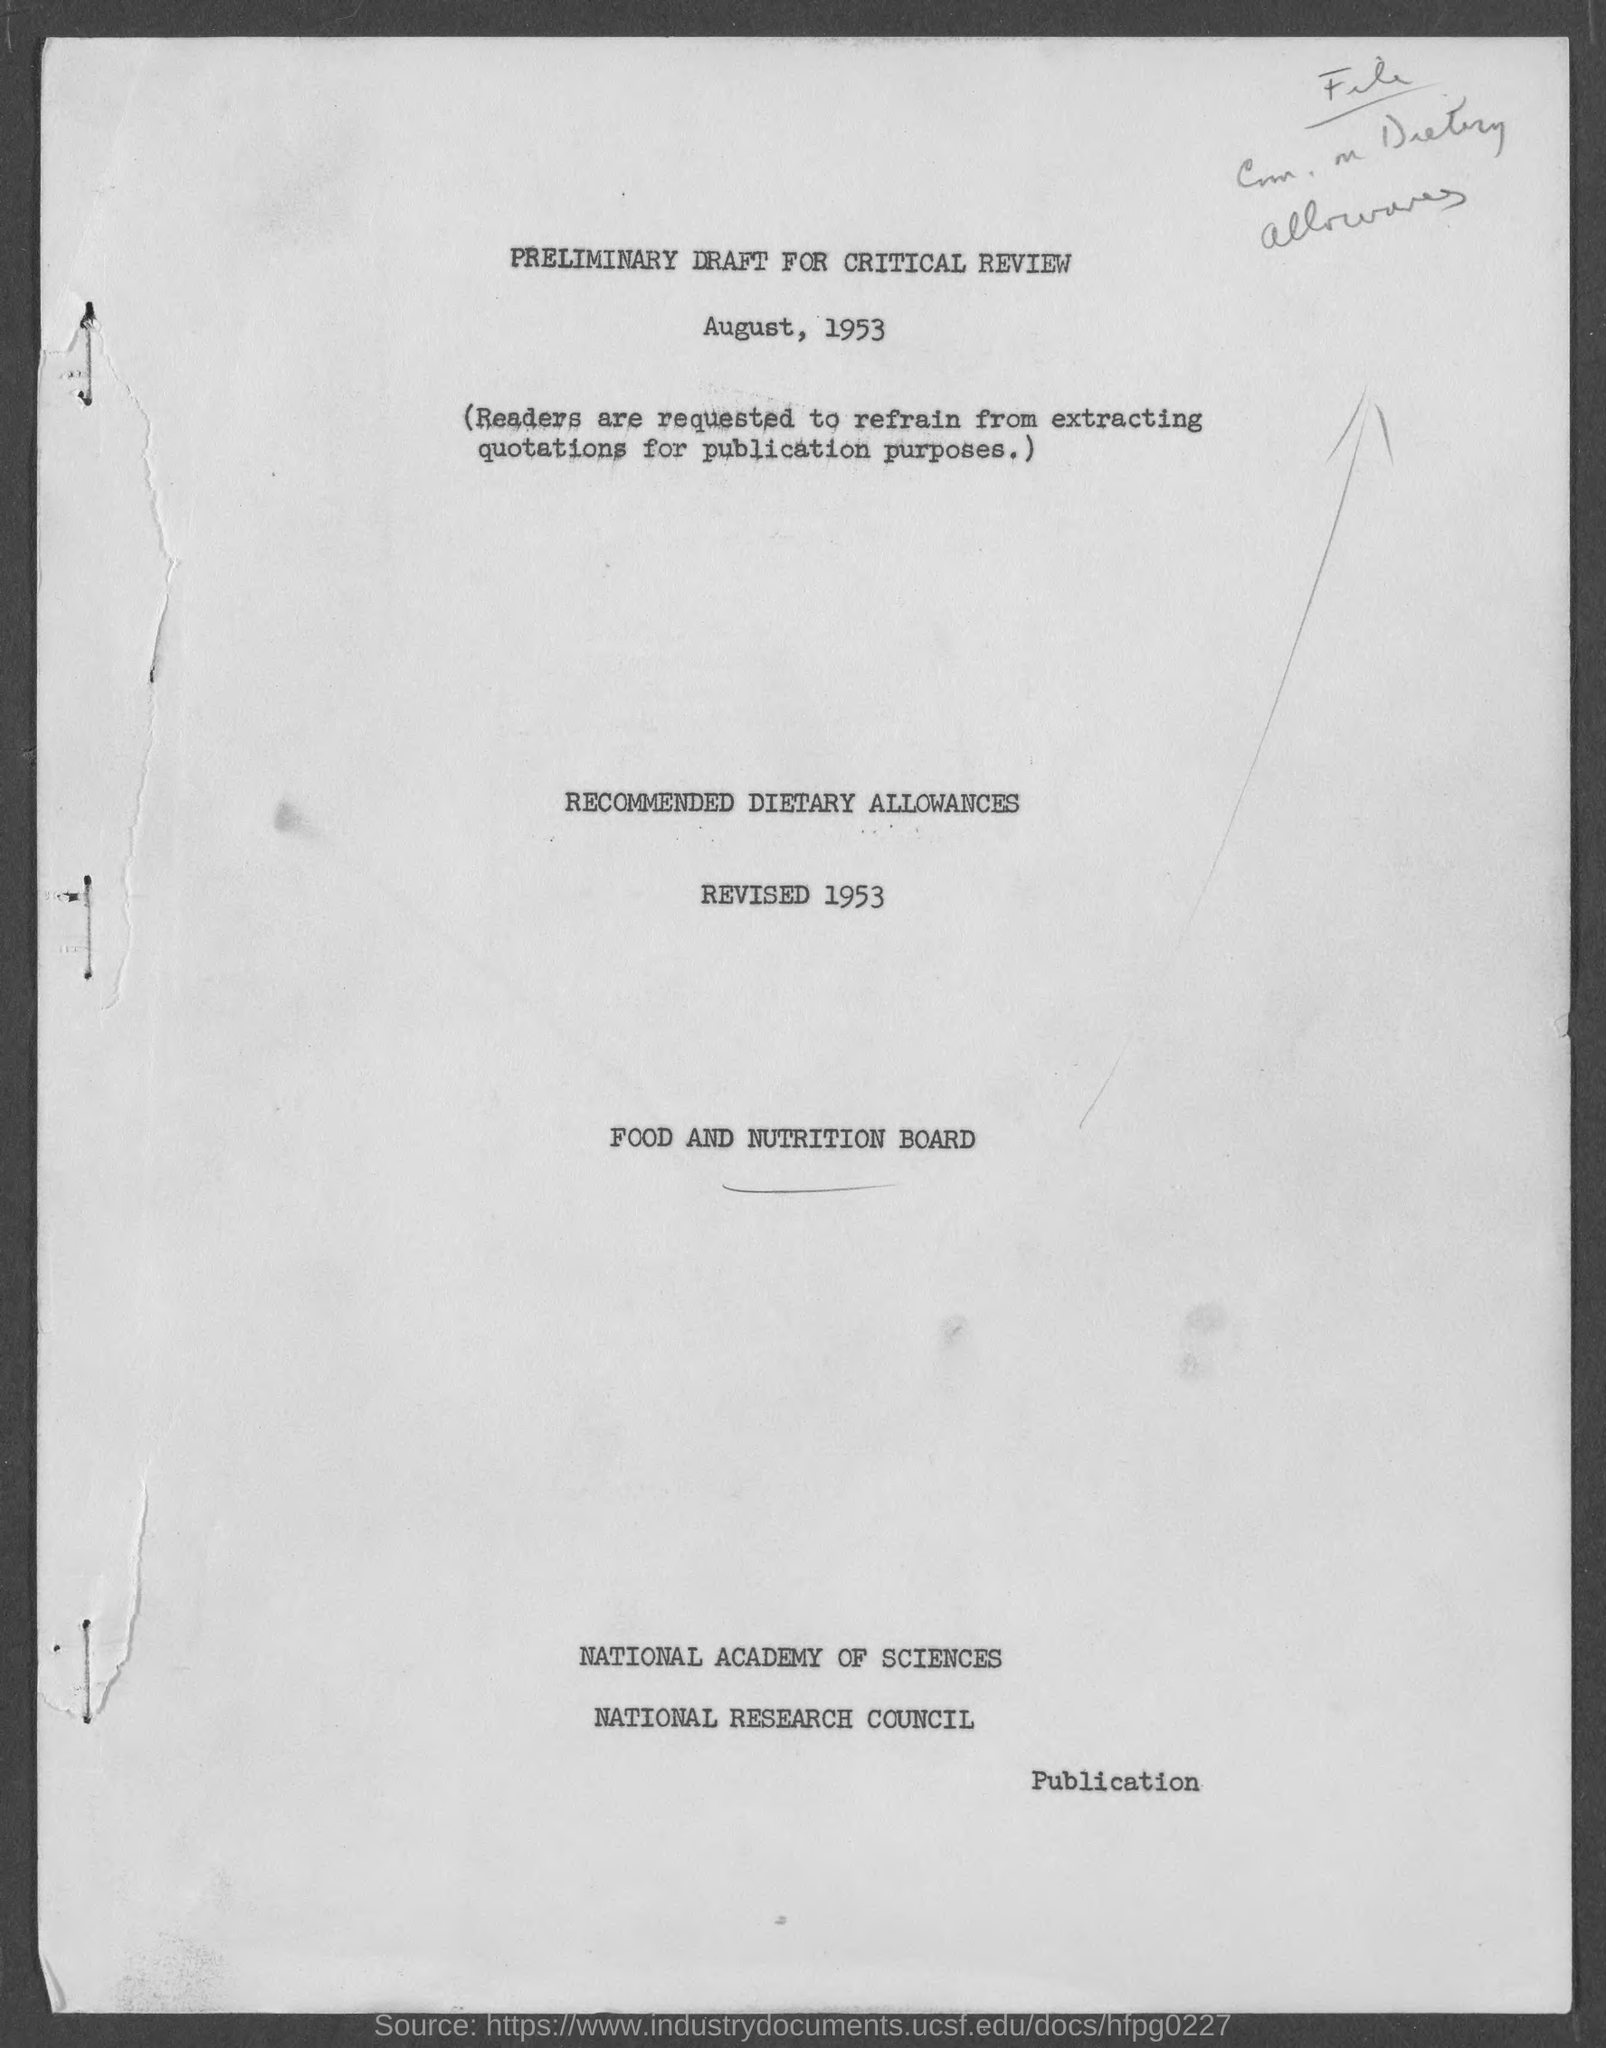What is the date mentioned for 'Preliminary draft for critical review'?
Make the answer very short. August, 1953. 